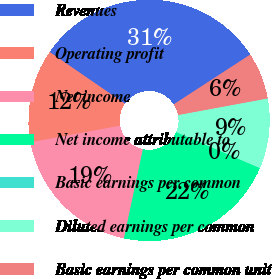Convert chart to OTSL. <chart><loc_0><loc_0><loc_500><loc_500><pie_chart><fcel>Revenues<fcel>Operating profit<fcel>Net income<fcel>Net income attributable to<fcel>Basic earnings per common<fcel>Diluted earnings per common<fcel>Basic earnings per common unit<nl><fcel>31.24%<fcel>12.5%<fcel>18.75%<fcel>21.87%<fcel>0.01%<fcel>9.38%<fcel>6.25%<nl></chart> 